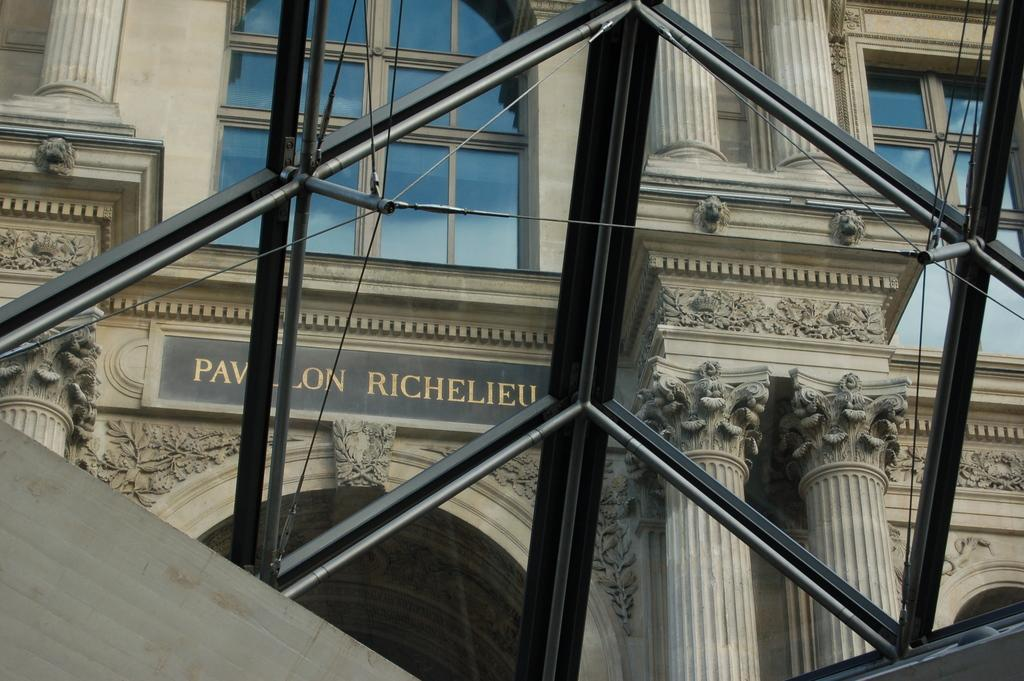What type of structure can be seen in the image? There is a fence in the image. What is visible in the background of the image? There is a building in the background of the image. What feature can be observed on the building? The building has glass windows. What is present on the wall of the building? There is a hoarding on the wall of the building. How many pets are visible in the image? There are no pets present in the image. What type of flock is flying over the building in the image? There is no flock visible in the image. 